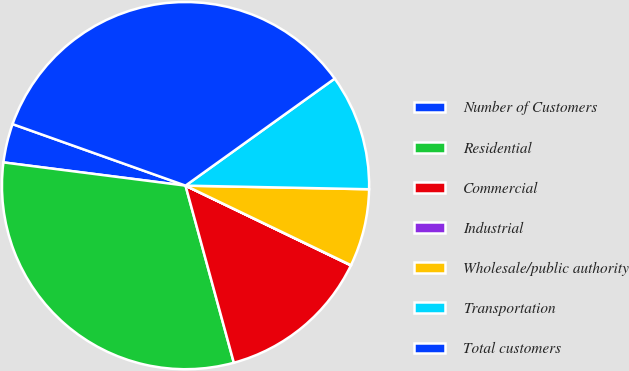Convert chart. <chart><loc_0><loc_0><loc_500><loc_500><pie_chart><fcel>Number of Customers<fcel>Residential<fcel>Commercial<fcel>Industrial<fcel>Wholesale/public authority<fcel>Transportation<fcel>Total customers<nl><fcel>3.42%<fcel>31.26%<fcel>13.61%<fcel>0.02%<fcel>6.82%<fcel>10.22%<fcel>34.66%<nl></chart> 